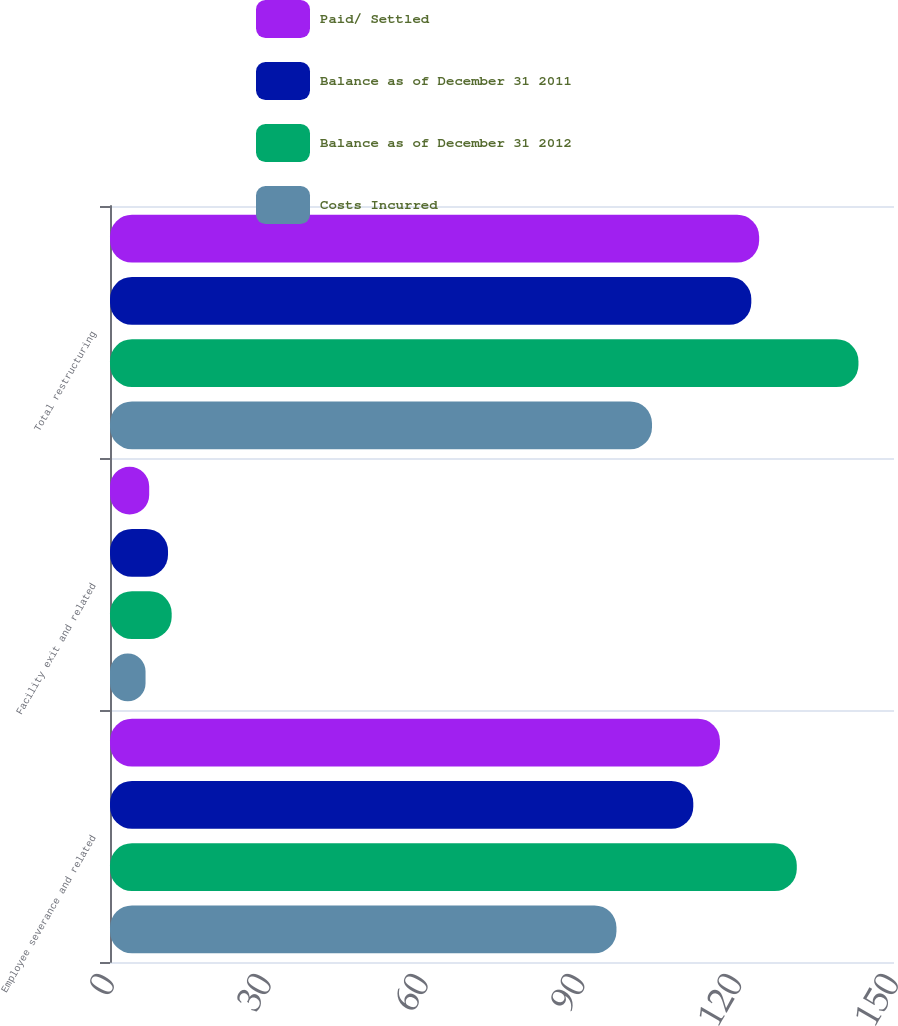Convert chart to OTSL. <chart><loc_0><loc_0><loc_500><loc_500><stacked_bar_chart><ecel><fcel>Employee severance and related<fcel>Facility exit and related<fcel>Total restructuring<nl><fcel>Paid/ Settled<fcel>116.7<fcel>7.5<fcel>124.2<nl><fcel>Balance as of December 31 2011<fcel>111.6<fcel>11.1<fcel>122.7<nl><fcel>Balance as of December 31 2012<fcel>131.4<fcel>11.8<fcel>143.2<nl><fcel>Costs Incurred<fcel>96.9<fcel>6.8<fcel>103.7<nl></chart> 